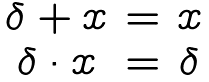Convert formula to latex. <formula><loc_0><loc_0><loc_500><loc_500>\begin{matrix} \delta + x & = & x \\ \delta \cdot x & = & \delta \end{matrix}</formula> 